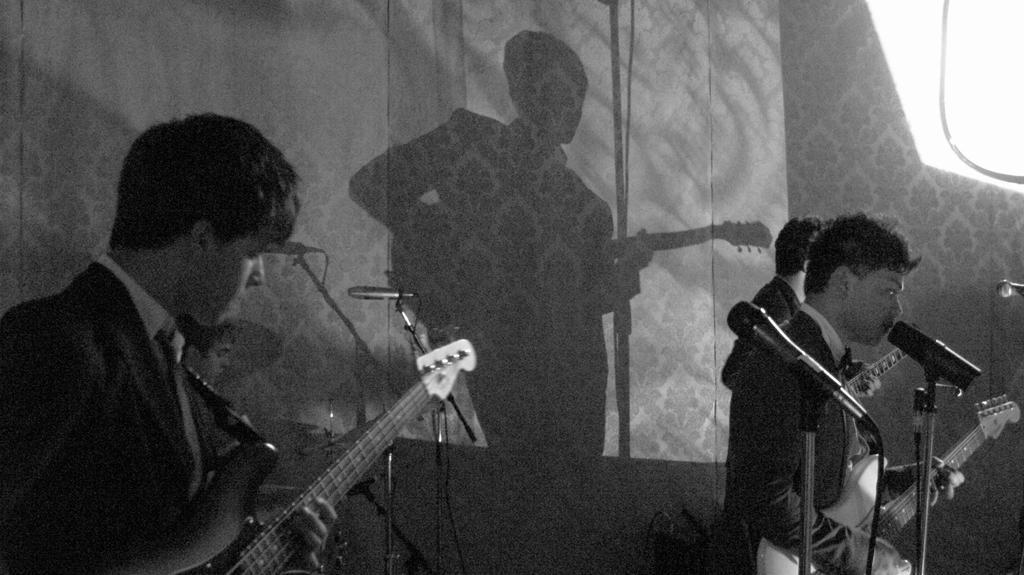How would you summarize this image in a sentence or two? In this image I can see two person playing a musical instruments. There are holding a guitar. There is a mic and stand. At the back side we can see the reflection of the man. 